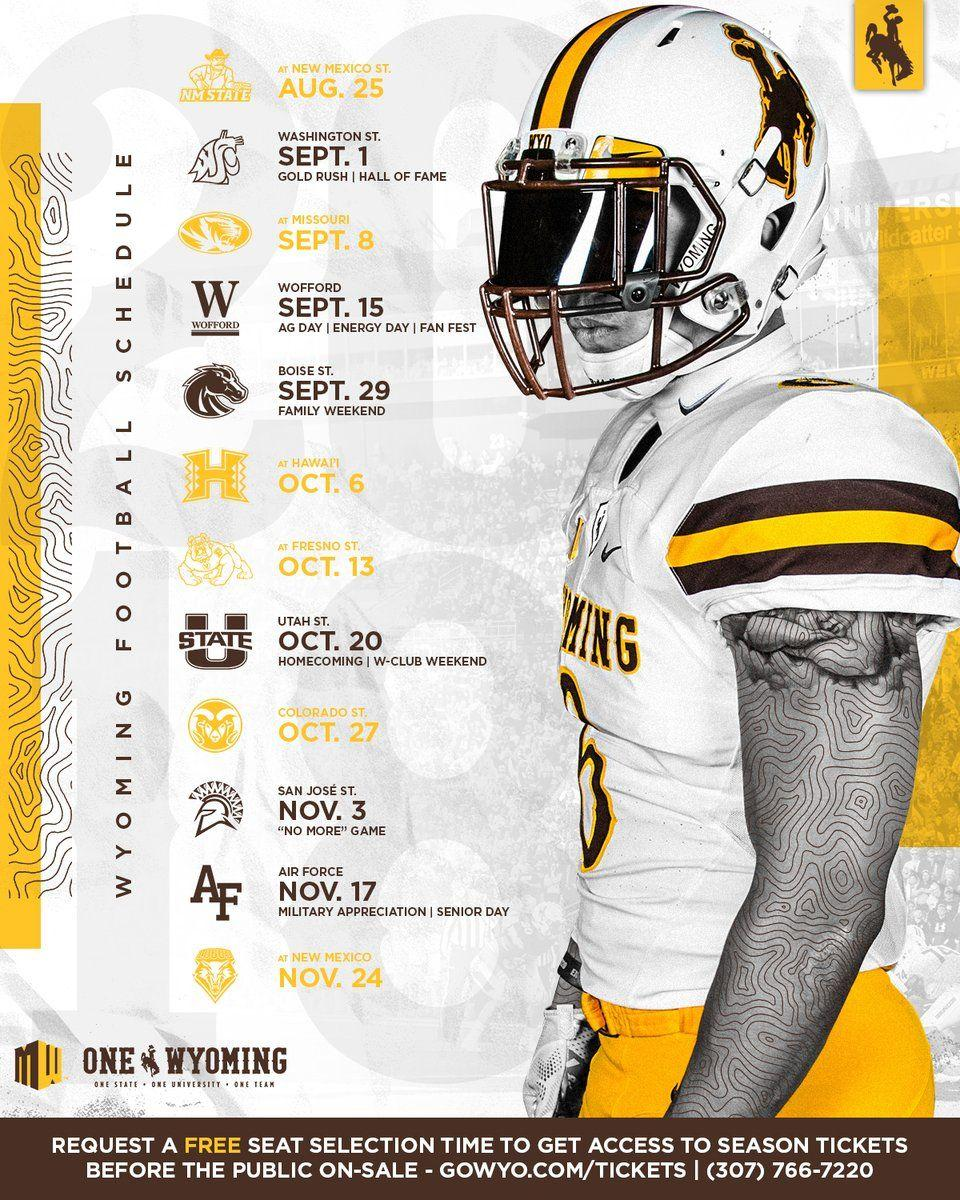Draw attention to some important aspects in this diagram. The logo of Wofford features the alphabet in a distinct and recognizable manner. The Air Force logo displays the letters "AF" in a specific font and design. These letters are the first and last letters of the abbreviation "Air Force," which is a branch of the military. The "AF" letters in the Air Force logo represent the symbol of this military branch, and they are an integral part of the logo's design. November 17th is senior day. A schedule has been shared, which includes the Wyoming football schedule for the given period. The color of the logo for Hawaii is yellow. 